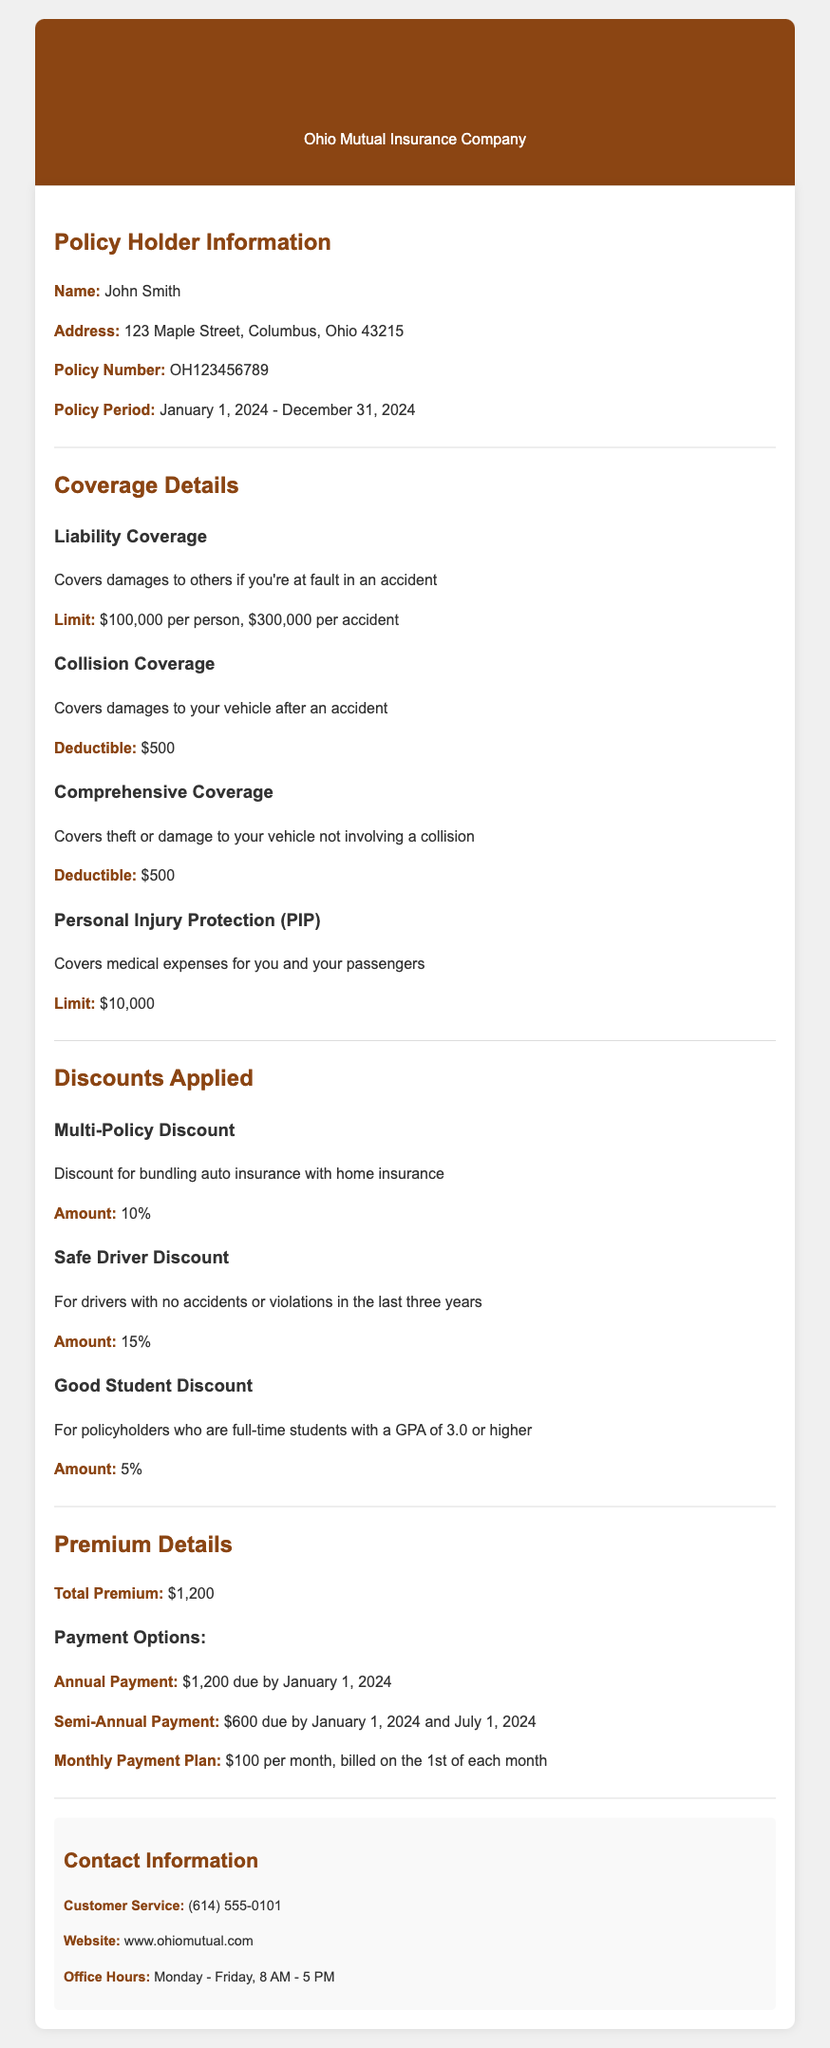What is the policy period? The policy period is stated directly in the document as January 1, 2024 - December 31, 2024.
Answer: January 1, 2024 - December 31, 2024 What is the deductible for collision coverage? The deductible for collision coverage is explicitly mentioned in the coverage details.
Answer: $500 What is the total premium amount? The total premium amount is noted in the premium details section.
Answer: $1,200 How much is the Safe Driver Discount? The document specifies the amount of the Safe Driver Discount under the discounts applied section.
Answer: 15% What types of payment options are provided? The document lists different payment options under the premium details section.
Answer: Annual Payment, Semi-Annual Payment, Monthly Payment Plan What is the liability coverage limit for accidents? The document provides specific coverage limits in the coverage details section.
Answer: $100,000 per person, $300,000 per accident How many discounts are applied to the policy? The document outlines three distinct discounts that are applied to the policy.
Answer: Three What is the contact number for customer service? The contact number is mentioned in the contact information section of the document.
Answer: (614) 555-0101 What is required to qualify for the Good Student Discount? The document specifies the criteria for the Good Student Discount in the discounts applied section.
Answer: Full-time student with a GPA of 3.0 or higher 